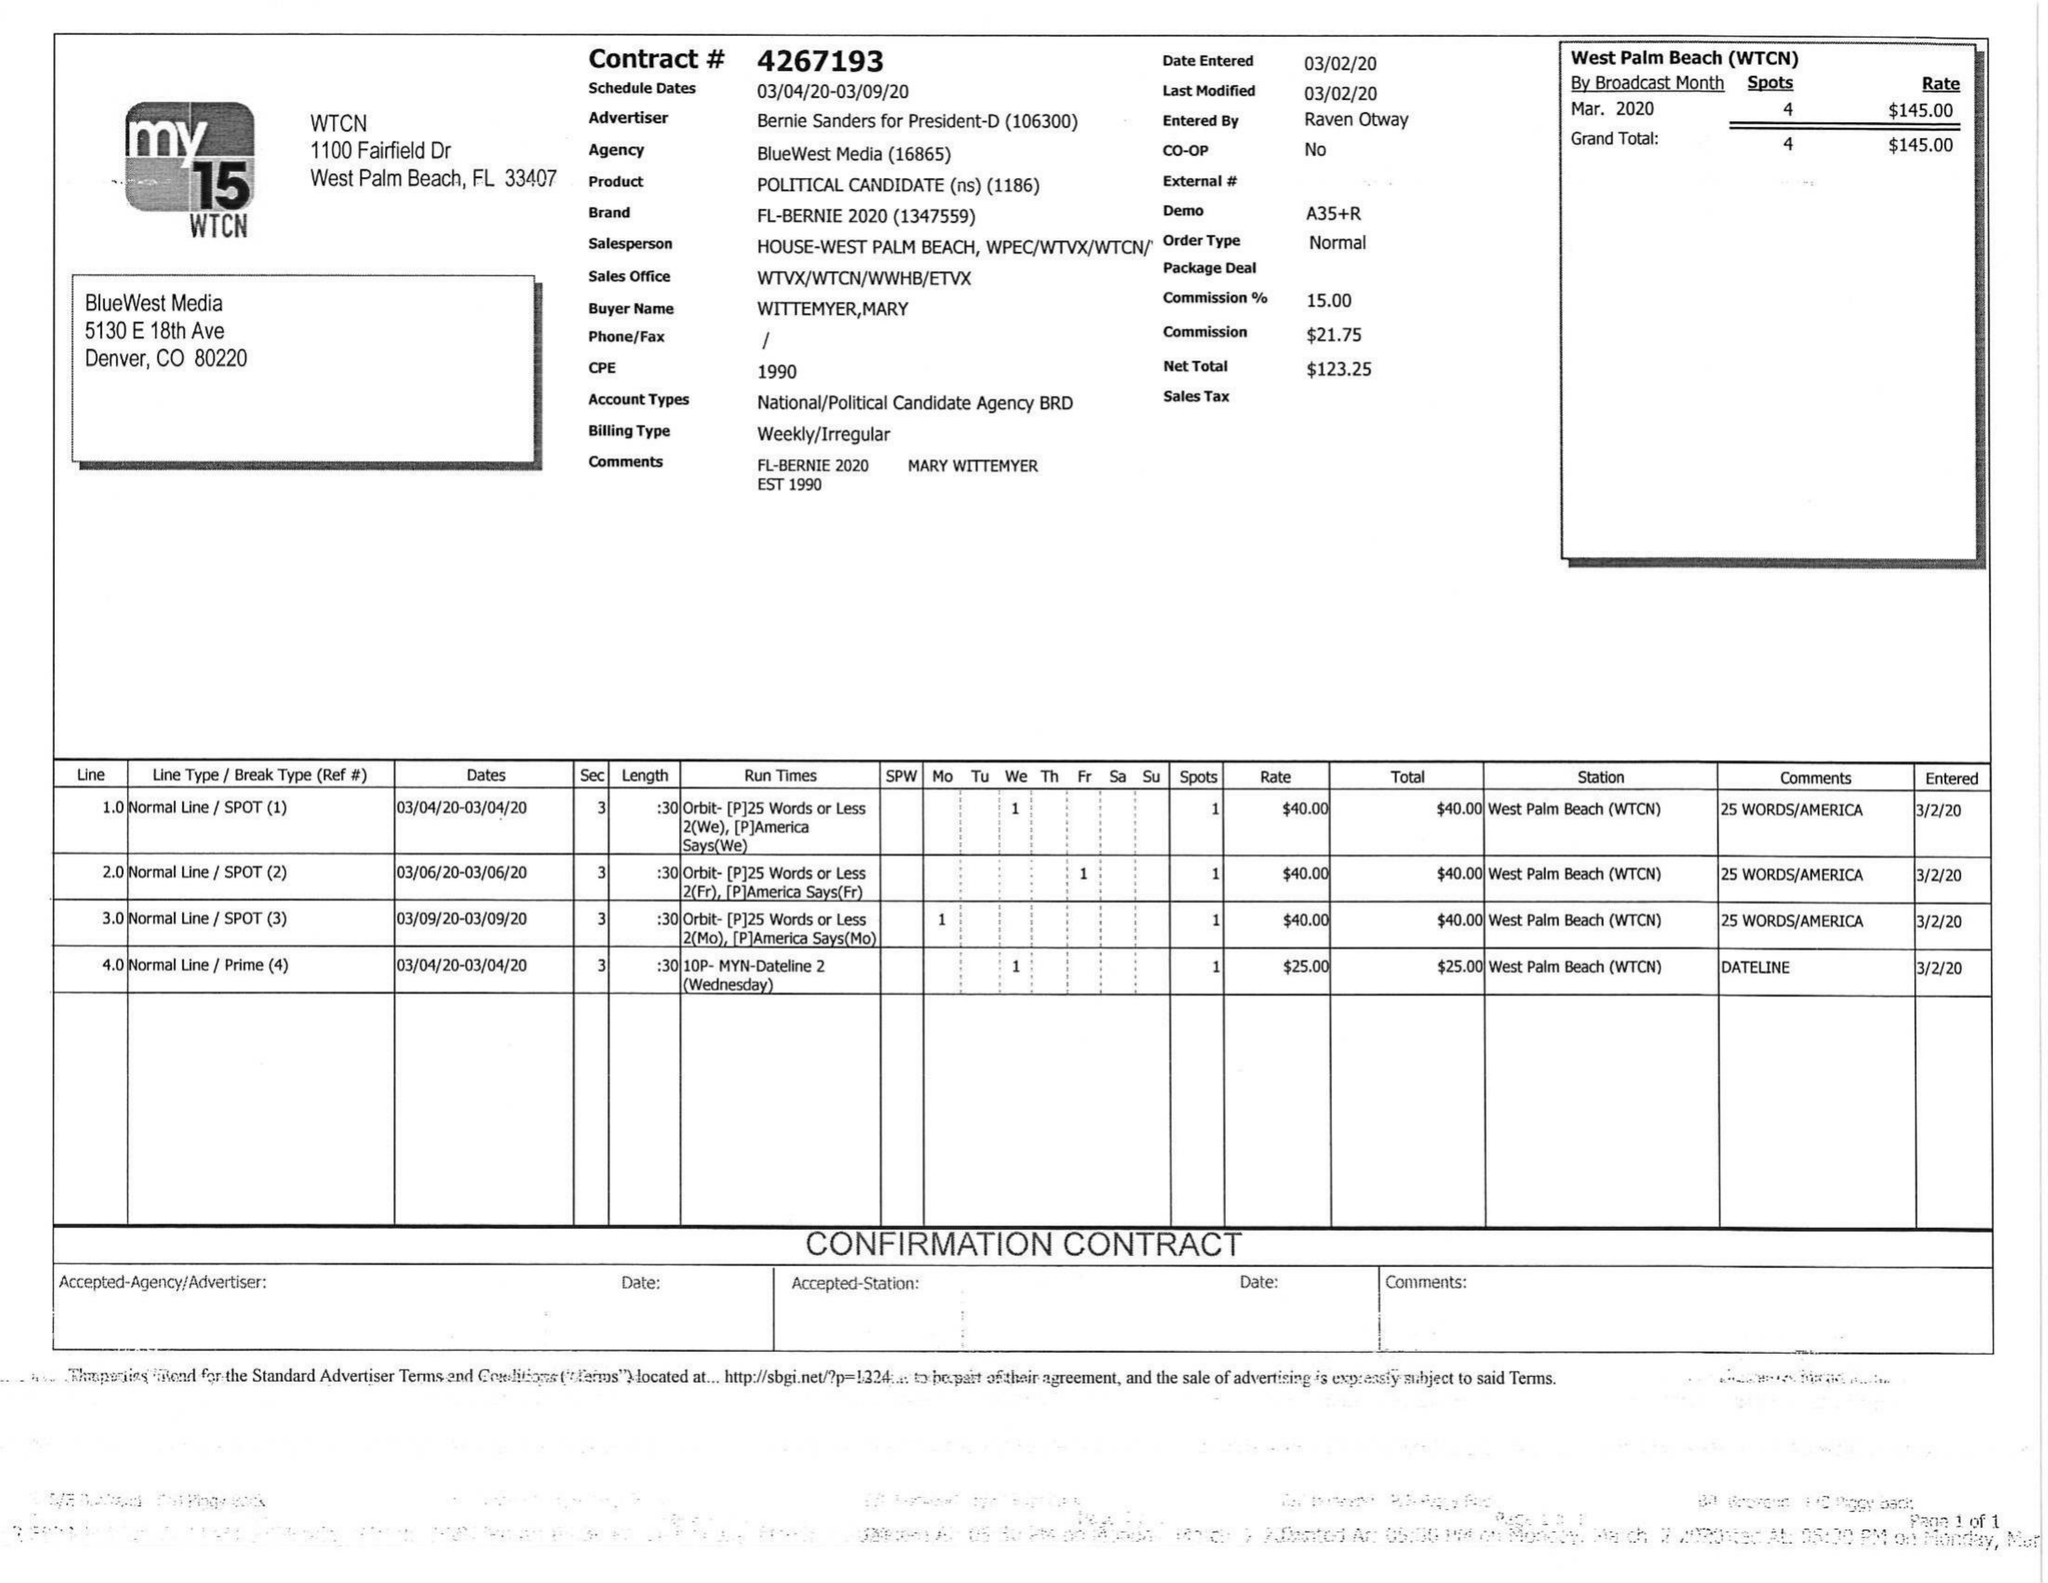What is the value for the contract_num?
Answer the question using a single word or phrase. 4267193 